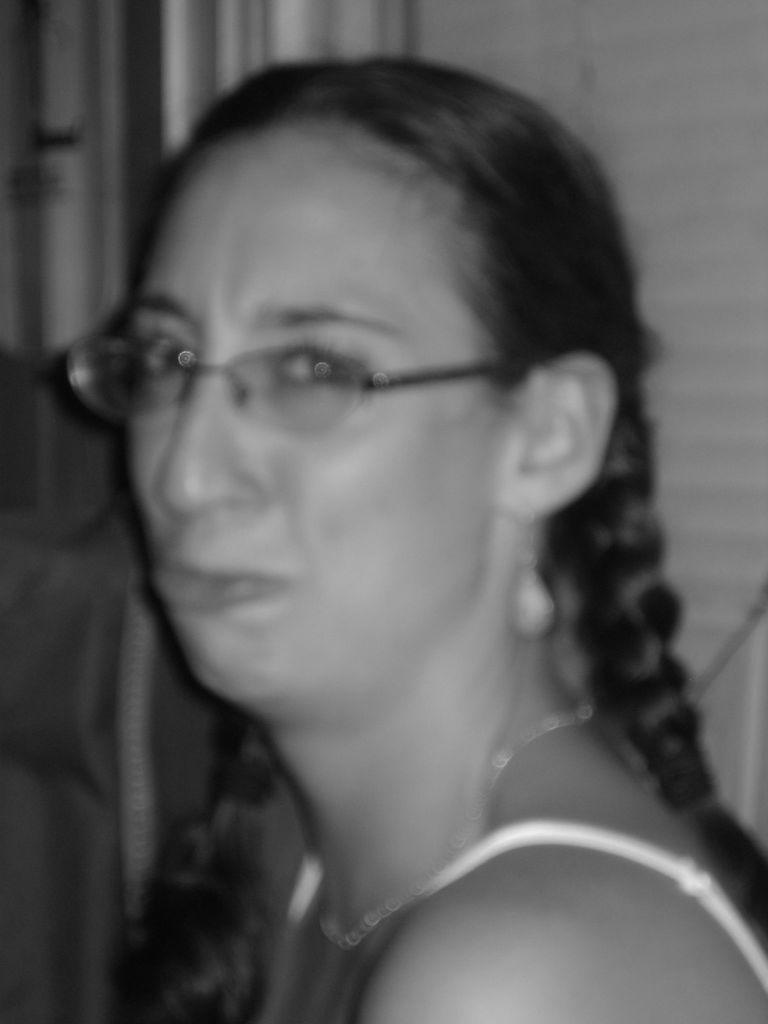What is the color scheme of the image? The image is black and white. What is the main subject of the image? There is a picture of a woman in the image. What type of baseball equipment can be seen in the image? There is no baseball equipment present in the image; it features a black and white picture of a woman. What substance is used to create the image? The image is black and white, but we cannot determine the specific substance used to create it from the image alone. 